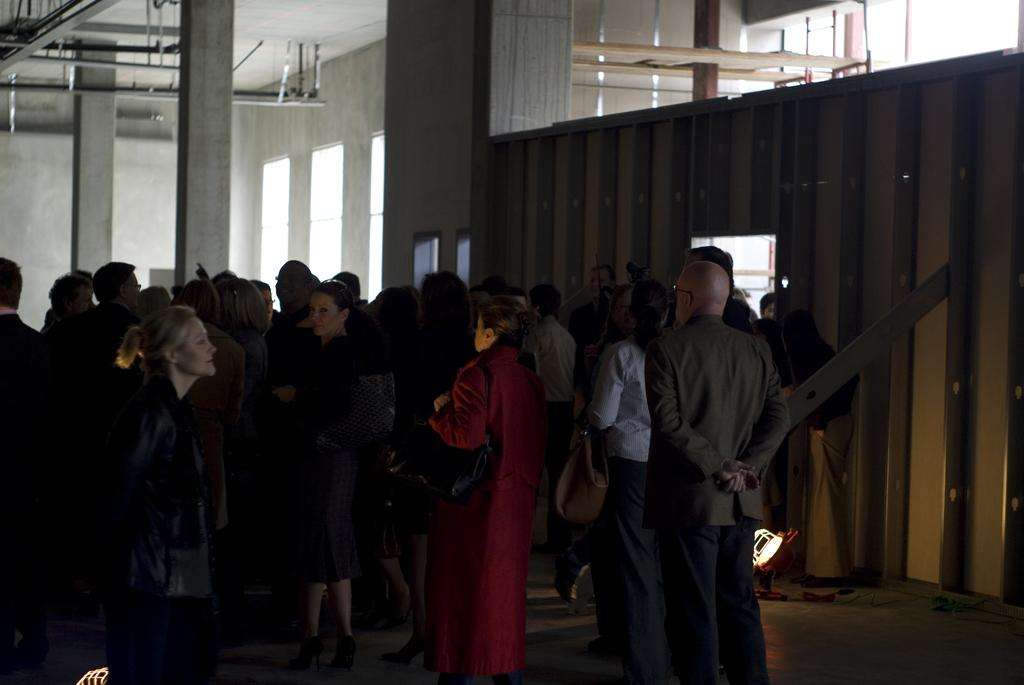What are the people in the image doing? The groups of people are standing in the image. What architectural features can be seen in the image? There are pillars and a wooden wall visible in the image. What can be seen through the windows in the image? The presence of windows suggests that there might be a view or other elements visible through them, but the specifics are not mentioned in the provided facts. How many screws are visible on the wooden wall in the image? There is no mention of screws in the provided facts, so it cannot be determined how many, if any, are visible on the wooden wall. 